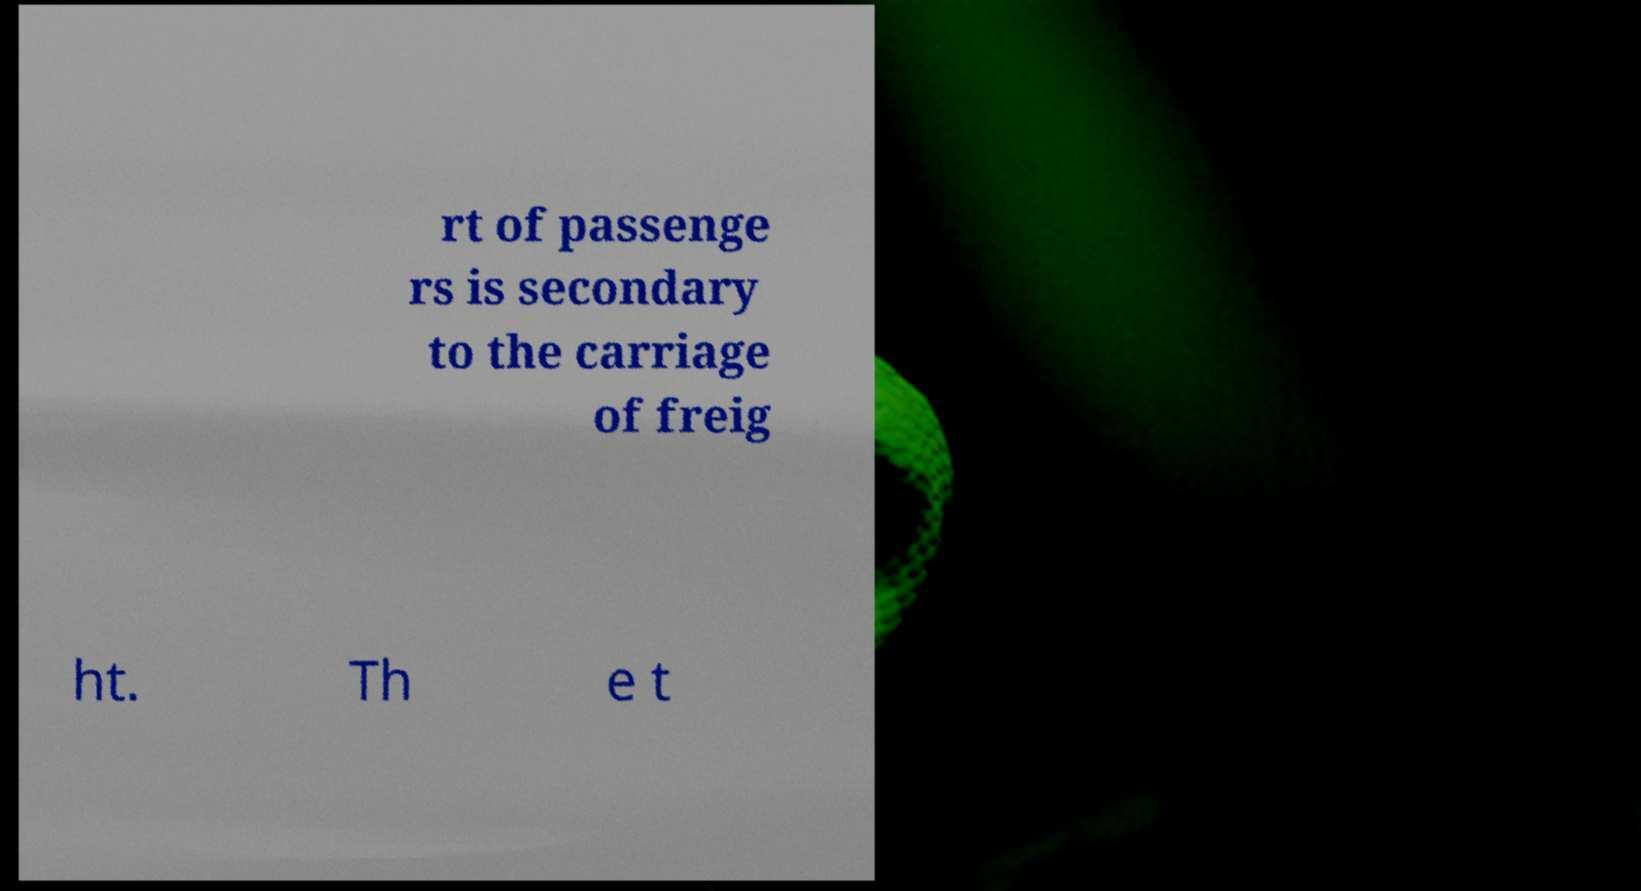Can you accurately transcribe the text from the provided image for me? rt of passenge rs is secondary to the carriage of freig ht. Th e t 